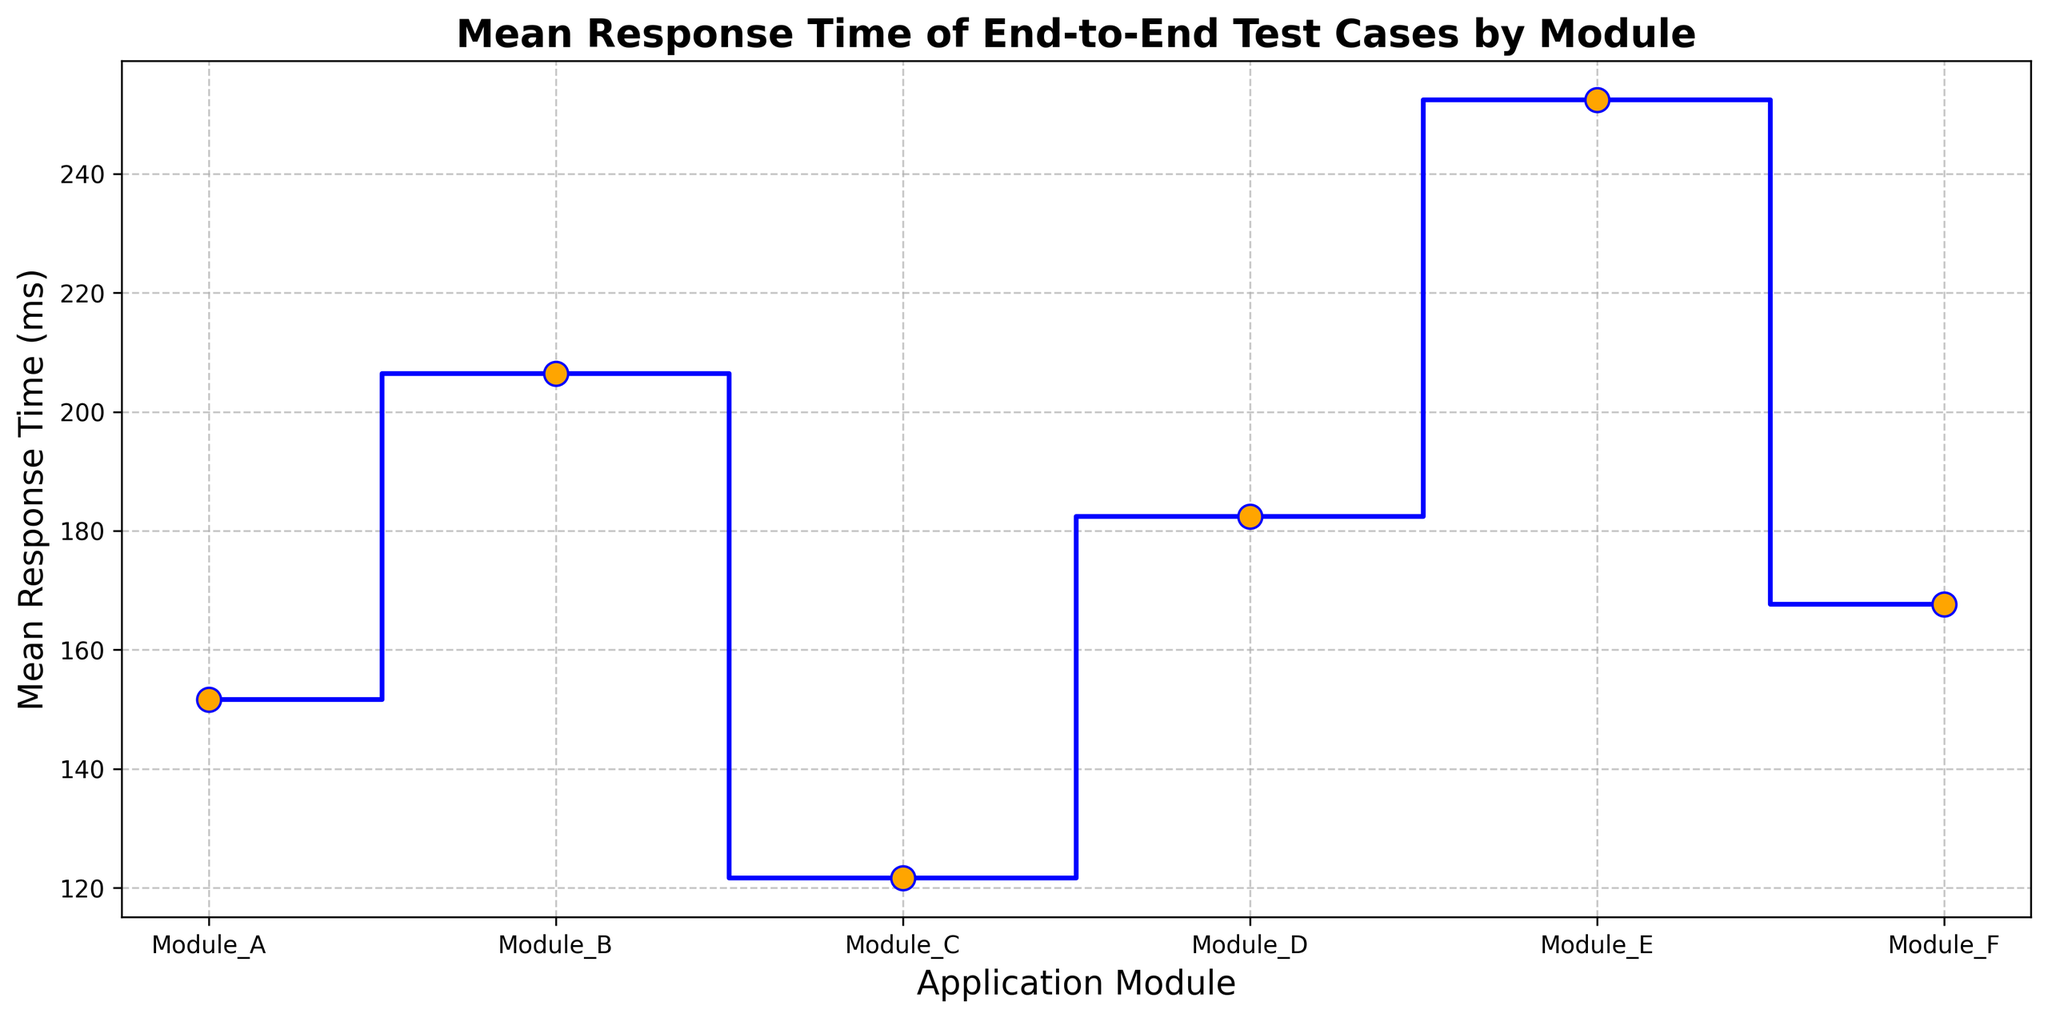Which application module has the highest mean response time? The module with the highest mean response time is identified by the highest step in the stairs plot. Module E has the highest mean as its step is the highest in the plot.
Answer: Module E What is the mean response time of Module B? Find the y-value of the step corresponding to Module B. The plot shows that the mean response time for Module B is around 206 ms.
Answer: 206 ms Which module has the lowest mean response time? The module with the lowest mean response time is identified by the lowest step in the stairs plot. Module C has the lowest mean response time.
Answer: Module C How does the mean response time of Module D compare to Module F's? Compare the heights of the steps for Module D and Module F. Module D's step is higher than Module F's, indicating a higher mean response time.
Answer: Module D's mean response time is higher What is the difference in mean response time between Module A and Module C? Calculate the difference between the mean response times of Module A (151.6 ms) and Module C (121.6 ms) by subtracting the lower value from the higher value. 151.6 ms - 121.6 ms = 30 ms
Answer: 30 ms Which two modules have the most similar mean response times? Determine the steps that are closest to each other vertically. Module D (182.4 ms) and Module F (167.6 ms) have the most similar mean response times.
Answer: Module D and Module F What is the average of the mean response times across all modules? Sum the mean response times of all modules and divide by the number of modules. (151.6 + 206.4 + 121.6 + 182.4 + 252.4 + 167.6) / 6 ≈ 180.33 ms
Answer: 180.33 ms By how many milliseconds does Module E's mean response time exceed Module B's? Find the difference between the mean response times of Module E (252.4 ms) and Module B (206.4 ms). 252.4 ms - 206.4 ms = 46 ms
Answer: 46 ms If the mean response time for Module B decreased by 10ms, how would it compare to Module D's mean response time? Subtract 10 ms from Module B's mean. 206.4 ms - 10 ms = 196.4 ms. Compare it to Module D's mean (182.4 ms). The adjusted mean for Module B would still be higher than Module D's.
Answer: B's mean would still be higher 